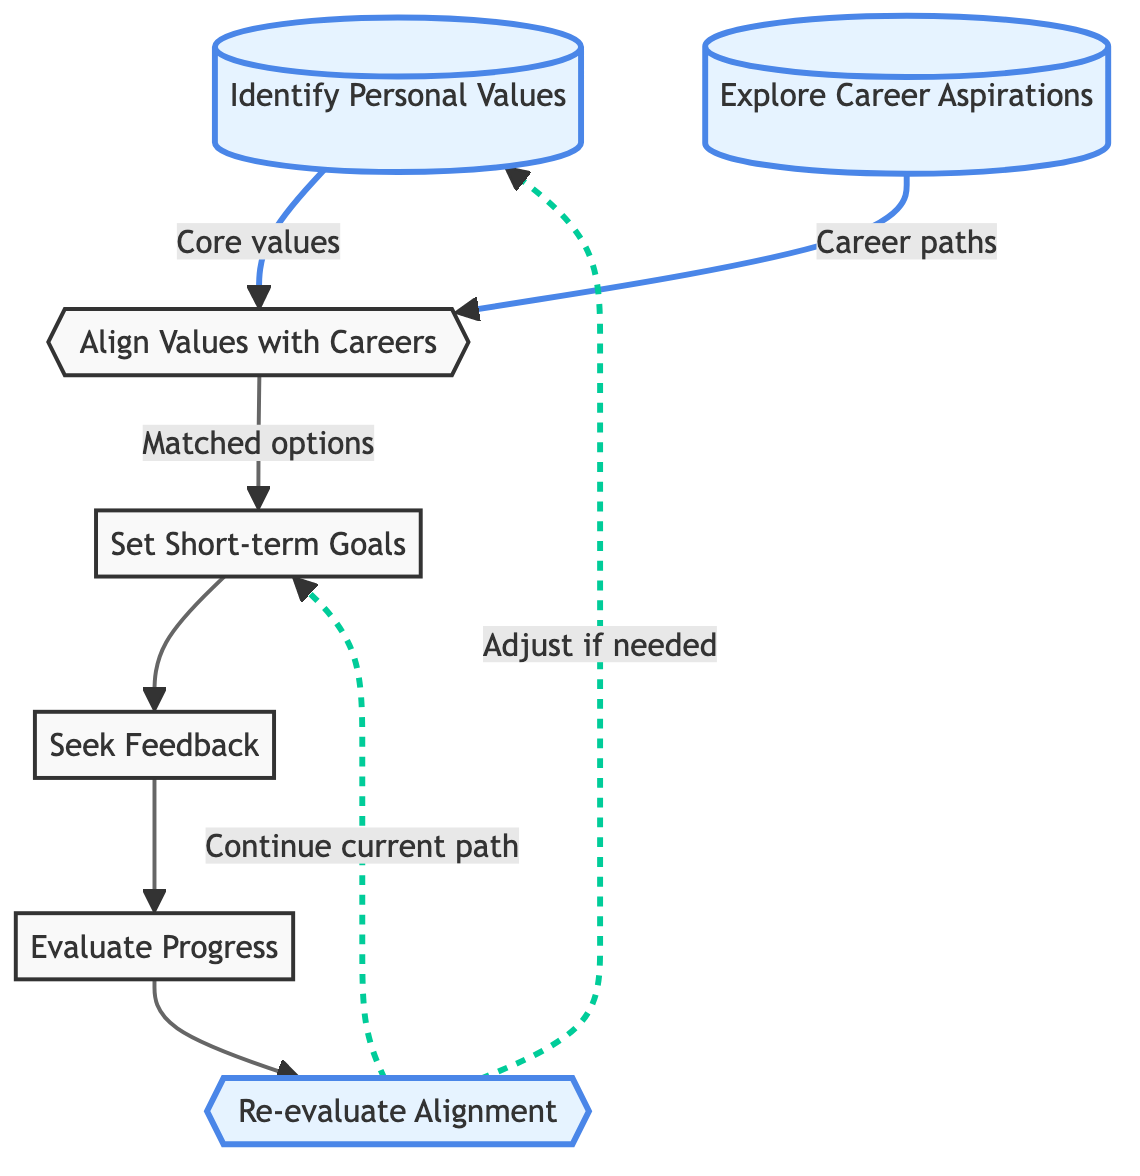What is the first step in the process? The first step is "Identify Personal Values." This can be determined by following the directional arrows in the flowchart from the starting point.
Answer: Identify Personal Values How many nodes are in the diagram? By counting all the unique elements represented in the diagram, we identify a total of seven nodes.
Answer: Seven What is the output of the "Align Values with Careers" step? The output of this step leads to the next action which is "Set Short-term Goals." The connection can be traced from node 3 to node 4 in the diagram.
Answer: Set Short-term Goals What follows after "Evaluate Progress"? After "Evaluate Progress," the next action according to the flowchart is "Re-evaluate Alignment," which can be seen directly from the output of node 6 leading to node 7.
Answer: Re-evaluate Alignment How many feedback loops are present in the chart? There is one main feedback loop illustrated: from "Re-evaluate Alignment" back to "Identify Personal Values." This indicates a cycle of reflection and adjustment based on personal values.
Answer: One What is the relationship between "Explore Career Aspirations" and "Align Values with Careers"? "Explore Career Aspirations" connects to "Align Values with Careers" as both nodes feed into the same step, contributing different aspects that aid the alignment process.
Answer: Both are inputs to Align Values with Careers What happens if the outcome of "Re-evaluate Alignment" indicates no changes are needed? If no changes are needed, the flowchart directs to "Continue current path," which indicates maintaining the existing career trajectory. This is shown by the arrow leading from node 7 to node 4.
Answer: Continue current path 